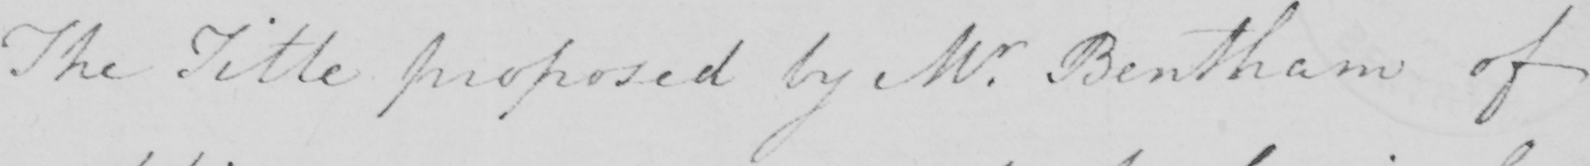Please provide the text content of this handwritten line. The Title proposed by Mr . Bentham of 